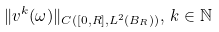<formula> <loc_0><loc_0><loc_500><loc_500>\| v ^ { k } ( \omega ) \| _ { C ( [ 0 , R ] , L ^ { 2 } ( B _ { R } ) ) } , \, k \in \mathbb { N }</formula> 